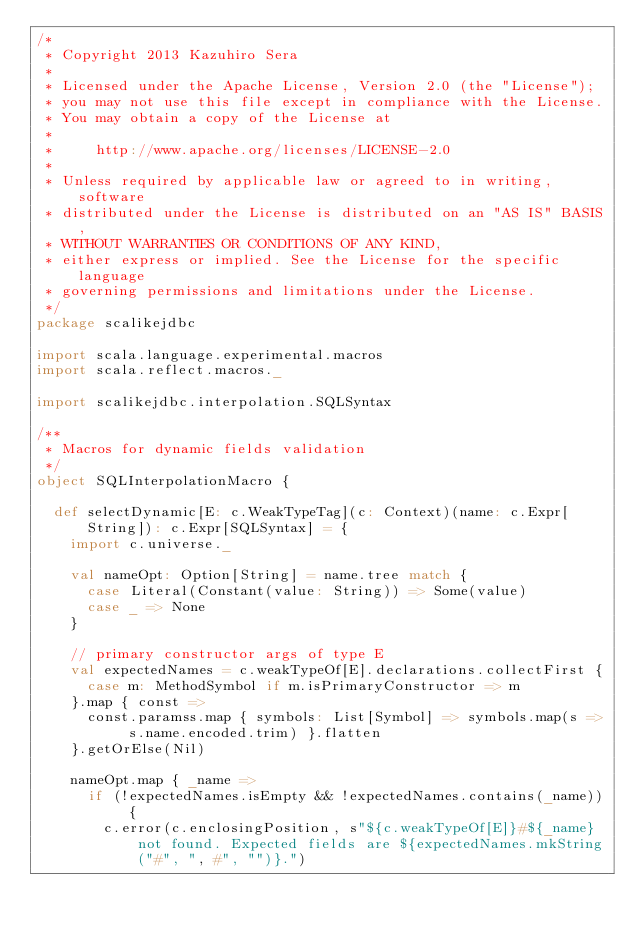Convert code to text. <code><loc_0><loc_0><loc_500><loc_500><_Scala_>/*
 * Copyright 2013 Kazuhiro Sera
 *
 * Licensed under the Apache License, Version 2.0 (the "License");
 * you may not use this file except in compliance with the License.
 * You may obtain a copy of the License at
 *
 *     http://www.apache.org/licenses/LICENSE-2.0
 *
 * Unless required by applicable law or agreed to in writing, software
 * distributed under the License is distributed on an "AS IS" BASIS,
 * WITHOUT WARRANTIES OR CONDITIONS OF ANY KIND,
 * either express or implied. See the License for the specific language
 * governing permissions and limitations under the License.
 */
package scalikejdbc

import scala.language.experimental.macros
import scala.reflect.macros._

import scalikejdbc.interpolation.SQLSyntax

/**
 * Macros for dynamic fields validation
 */
object SQLInterpolationMacro {

  def selectDynamic[E: c.WeakTypeTag](c: Context)(name: c.Expr[String]): c.Expr[SQLSyntax] = {
    import c.universe._

    val nameOpt: Option[String] = name.tree match {
      case Literal(Constant(value: String)) => Some(value)
      case _ => None
    }

    // primary constructor args of type E
    val expectedNames = c.weakTypeOf[E].declarations.collectFirst {
      case m: MethodSymbol if m.isPrimaryConstructor => m
    }.map { const =>
      const.paramss.map { symbols: List[Symbol] => symbols.map(s => s.name.encoded.trim) }.flatten
    }.getOrElse(Nil)

    nameOpt.map { _name =>
      if (!expectedNames.isEmpty && !expectedNames.contains(_name)) {
        c.error(c.enclosingPosition, s"${c.weakTypeOf[E]}#${_name} not found. Expected fields are ${expectedNames.mkString("#", ", #", "")}.")</code> 